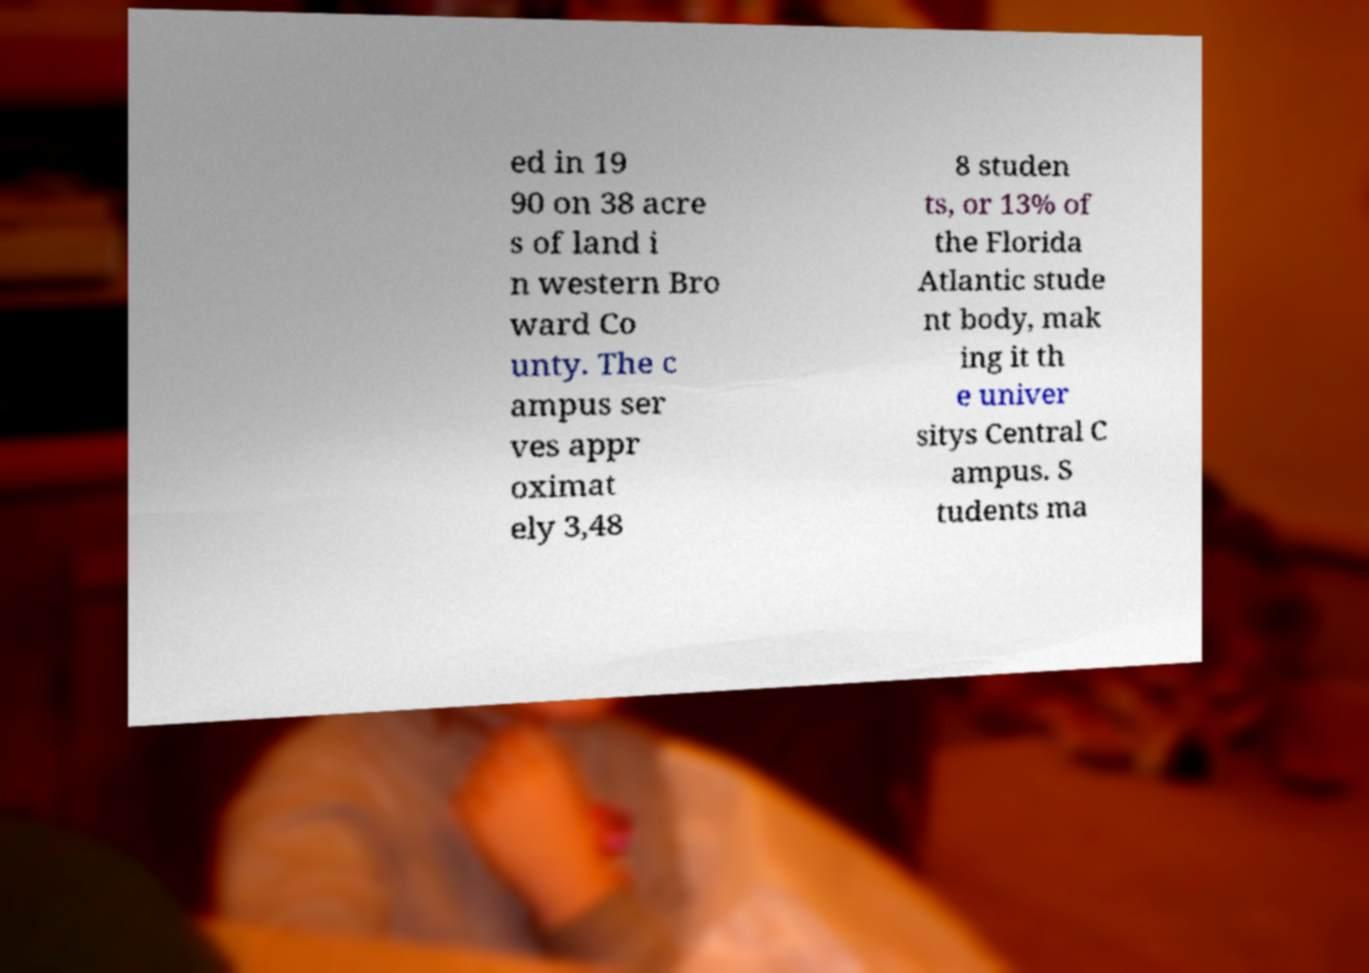Can you read and provide the text displayed in the image?This photo seems to have some interesting text. Can you extract and type it out for me? ed in 19 90 on 38 acre s of land i n western Bro ward Co unty. The c ampus ser ves appr oximat ely 3,48 8 studen ts, or 13% of the Florida Atlantic stude nt body, mak ing it th e univer sitys Central C ampus. S tudents ma 